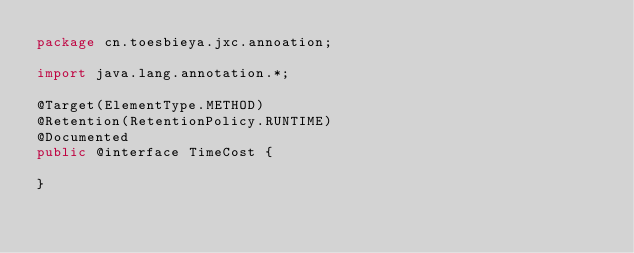Convert code to text. <code><loc_0><loc_0><loc_500><loc_500><_Java_>package cn.toesbieya.jxc.annoation;

import java.lang.annotation.*;

@Target(ElementType.METHOD)
@Retention(RetentionPolicy.RUNTIME)
@Documented
public @interface TimeCost {

}
</code> 